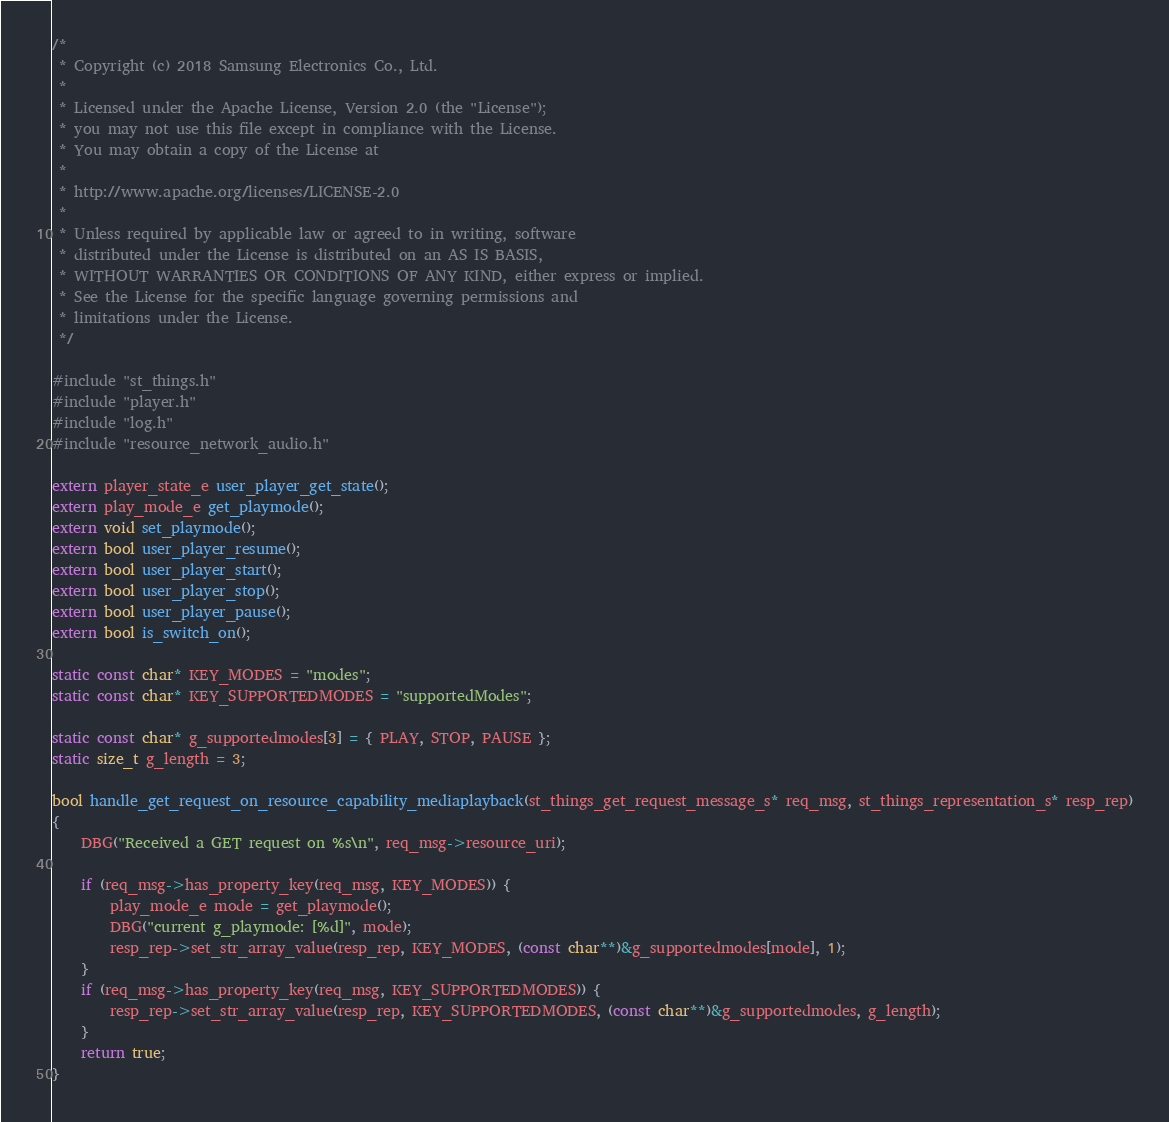Convert code to text. <code><loc_0><loc_0><loc_500><loc_500><_C_>/*
 * Copyright (c) 2018 Samsung Electronics Co., Ltd.
 *
 * Licensed under the Apache License, Version 2.0 (the "License");
 * you may not use this file except in compliance with the License.
 * You may obtain a copy of the License at
 *
 * http://www.apache.org/licenses/LICENSE-2.0
 *
 * Unless required by applicable law or agreed to in writing, software
 * distributed under the License is distributed on an AS IS BASIS,
 * WITHOUT WARRANTIES OR CONDITIONS OF ANY KIND, either express or implied.
 * See the License for the specific language governing permissions and
 * limitations under the License.
 */

#include "st_things.h"
#include "player.h"
#include "log.h"
#include "resource_network_audio.h"

extern player_state_e user_player_get_state();
extern play_mode_e get_playmode();
extern void set_playmode();
extern bool user_player_resume();
extern bool user_player_start();
extern bool user_player_stop();
extern bool user_player_pause();
extern bool is_switch_on();

static const char* KEY_MODES = "modes";
static const char* KEY_SUPPORTEDMODES = "supportedModes";

static const char* g_supportedmodes[3] = { PLAY, STOP, PAUSE };
static size_t g_length = 3;

bool handle_get_request_on_resource_capability_mediaplayback(st_things_get_request_message_s* req_msg, st_things_representation_s* resp_rep)
{
    DBG("Received a GET request on %s\n", req_msg->resource_uri);

    if (req_msg->has_property_key(req_msg, KEY_MODES)) {
        play_mode_e mode = get_playmode();
        DBG("current g_playmode: [%d]", mode);
        resp_rep->set_str_array_value(resp_rep, KEY_MODES, (const char**)&g_supportedmodes[mode], 1);
    }
    if (req_msg->has_property_key(req_msg, KEY_SUPPORTEDMODES)) {
		resp_rep->set_str_array_value(resp_rep, KEY_SUPPORTEDMODES, (const char**)&g_supportedmodes, g_length);
    }
    return true;
}
</code> 